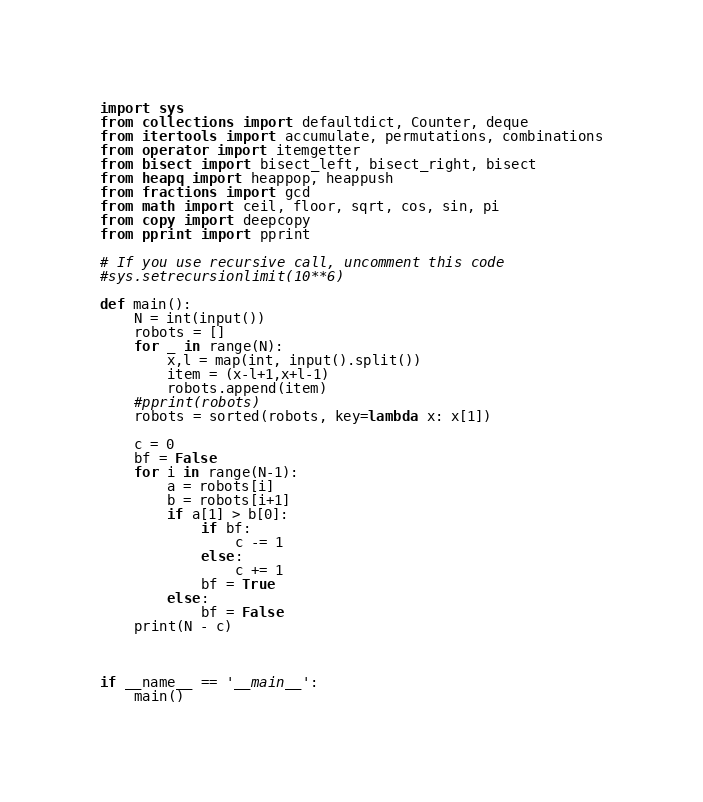Convert code to text. <code><loc_0><loc_0><loc_500><loc_500><_Python_>import sys
from collections import defaultdict, Counter, deque
from itertools import accumulate, permutations, combinations
from operator import itemgetter
from bisect import bisect_left, bisect_right, bisect
from heapq import heappop, heappush
from fractions import gcd
from math import ceil, floor, sqrt, cos, sin, pi
from copy import deepcopy
from pprint import pprint

# If you use recursive call, uncomment this code
#sys.setrecursionlimit(10**6)

def main():
    N = int(input())
    robots = []
    for _ in range(N):
        x,l = map(int, input().split())
        item = (x-l+1,x+l-1)
        robots.append(item)
    #pprint(robots)
    robots = sorted(robots, key=lambda x: x[1])
    
    c = 0
    bf = False
    for i in range(N-1):
        a = robots[i]
        b = robots[i+1]
        if a[1] > b[0]:
            if bf:
                c -= 1
            else:
                c += 1
            bf = True
        else:
            bf = False
    print(N - c)



if __name__ == '__main__':
    main()
</code> 